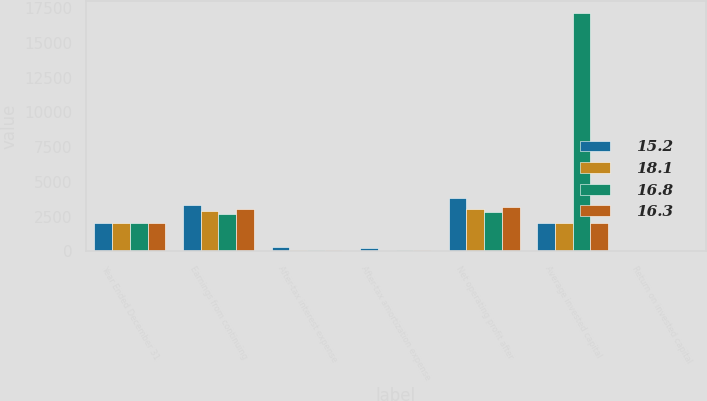Convert chart. <chart><loc_0><loc_0><loc_500><loc_500><stacked_bar_chart><ecel><fcel>Year Ended December 31<fcel>Earnings from continuing<fcel>After-tax interest expense<fcel>After-tax amortization expense<fcel>Net operating profit after<fcel>Average invested capital<fcel>Return on invested capital<nl><fcel>15.2<fcel>2018<fcel>3358<fcel>295<fcel>213<fcel>3866<fcel>2015<fcel>15.2<nl><fcel>18.1<fcel>2017<fcel>2912<fcel>76<fcel>51<fcel>3039<fcel>2015<fcel>16.8<nl><fcel>16.8<fcel>2016<fcel>2679<fcel>64<fcel>57<fcel>2800<fcel>17168<fcel>16.3<nl><fcel>16.3<fcel>2015<fcel>3036<fcel>64<fcel>75<fcel>3175<fcel>2015<fcel>18.1<nl></chart> 